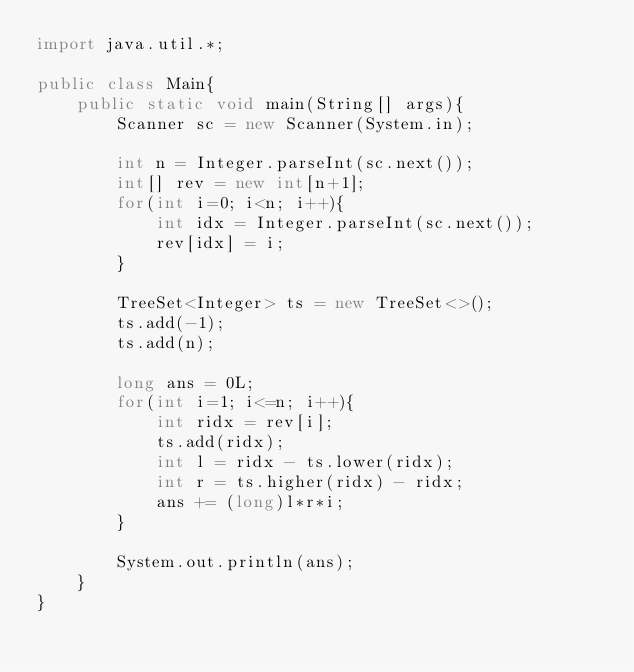<code> <loc_0><loc_0><loc_500><loc_500><_Java_>import java.util.*;

public class Main{
    public static void main(String[] args){
        Scanner sc = new Scanner(System.in);
        
        int n = Integer.parseInt(sc.next());
        int[] rev = new int[n+1];
        for(int i=0; i<n; i++){
            int idx = Integer.parseInt(sc.next());
            rev[idx] = i;
        }
        
        TreeSet<Integer> ts = new TreeSet<>();
        ts.add(-1);
        ts.add(n);
        
        long ans = 0L;
        for(int i=1; i<=n; i++){
            int ridx = rev[i];
            ts.add(ridx);
            int l = ridx - ts.lower(ridx);
            int r = ts.higher(ridx) - ridx;
            ans += (long)l*r*i;
        }
        
        System.out.println(ans);
    }
}

</code> 